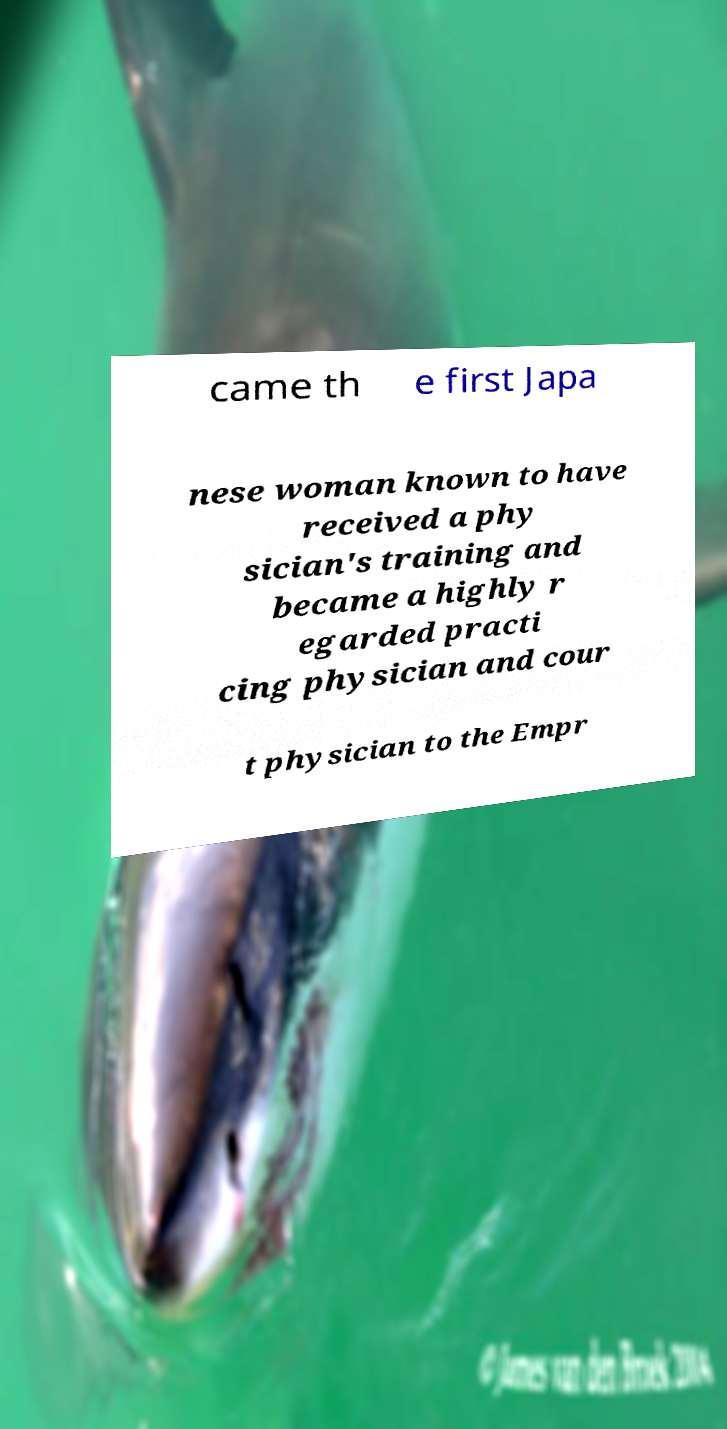There's text embedded in this image that I need extracted. Can you transcribe it verbatim? came th e first Japa nese woman known to have received a phy sician's training and became a highly r egarded practi cing physician and cour t physician to the Empr 